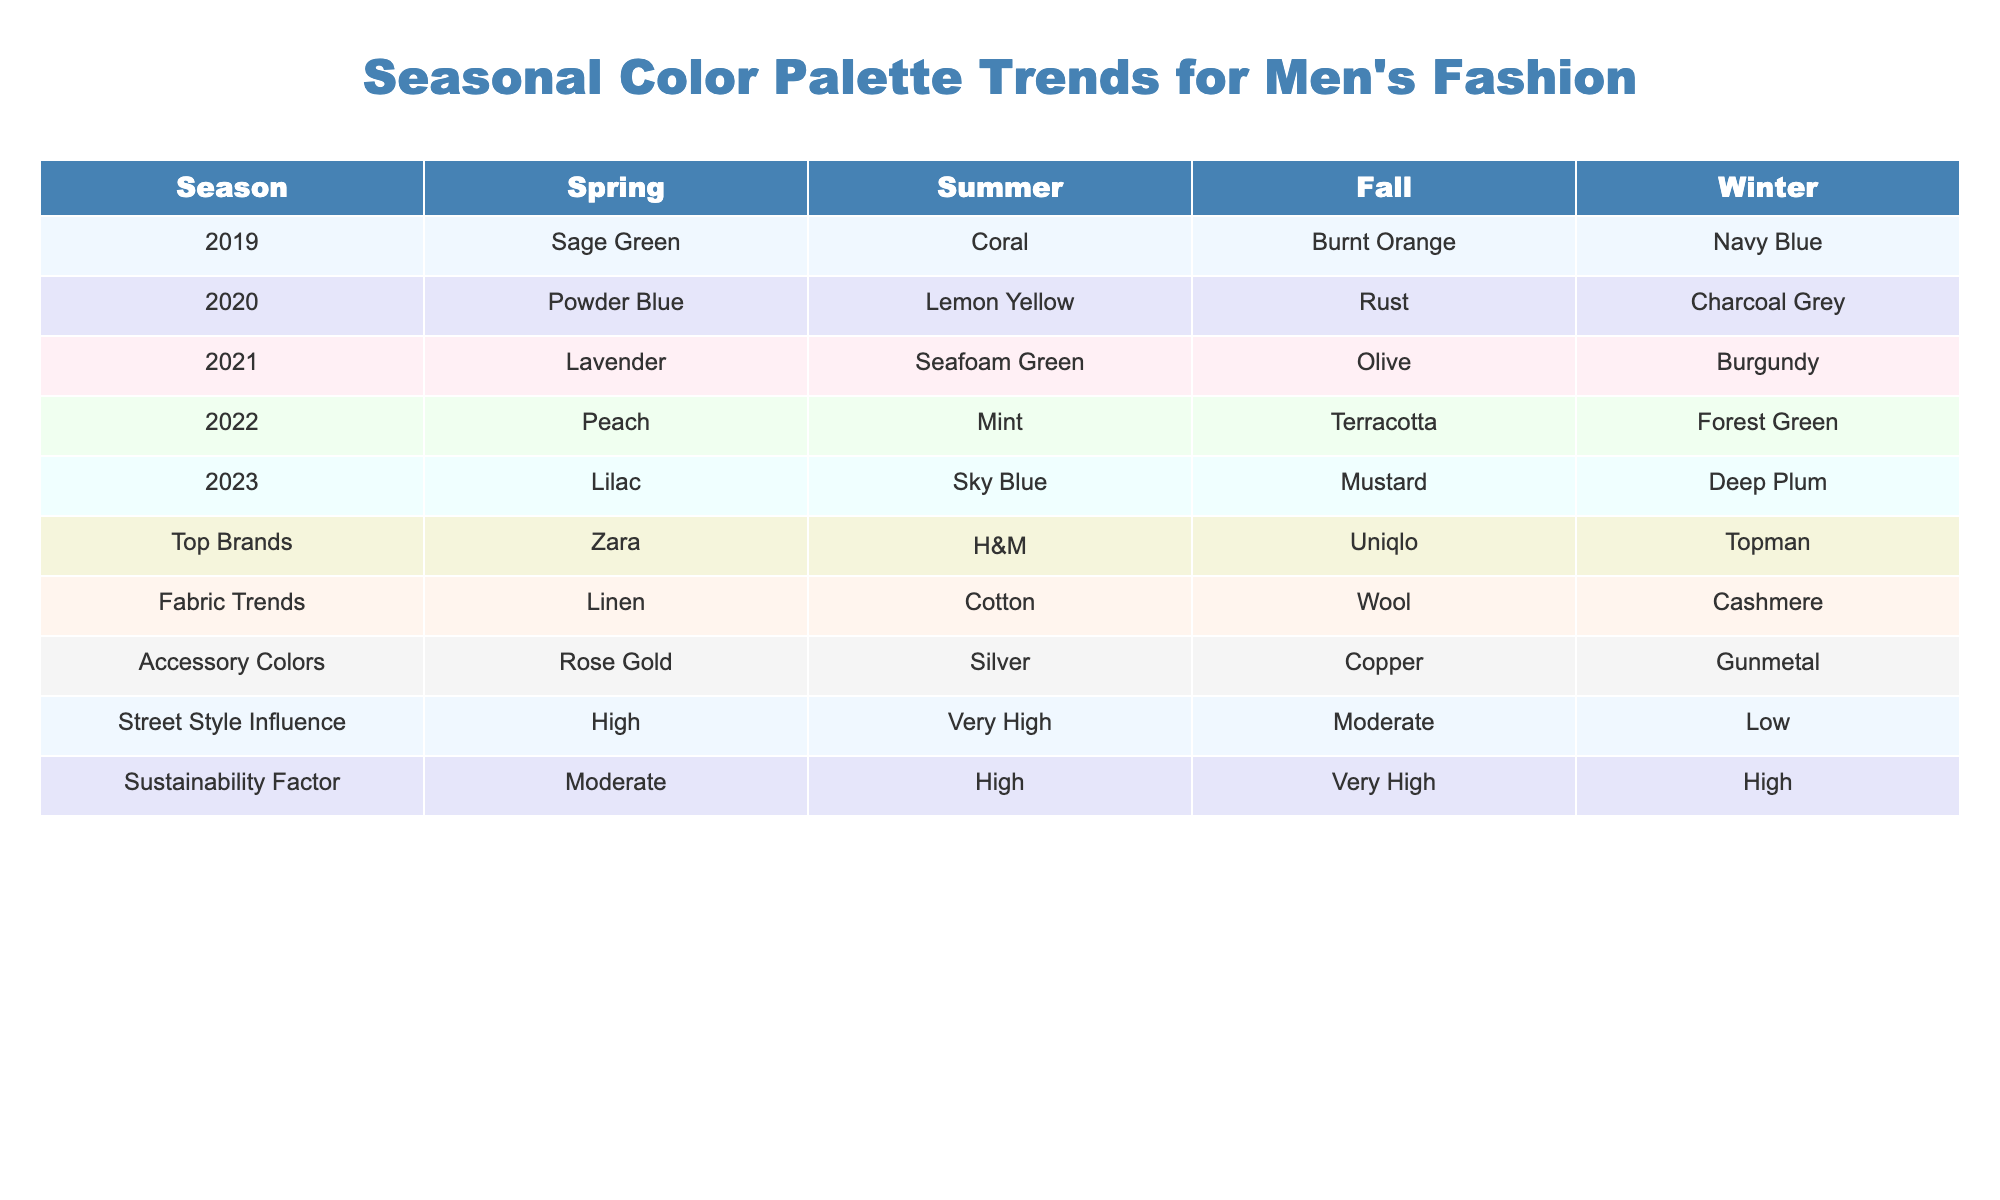What was the color for Spring 2022? The table lists the Spring color for 2022 as Peach.
Answer: Peach Which color was used for Winter in 2020? According to the table, the color for Winter in 2020 was Charcoal Grey.
Answer: Charcoal Grey What is the top brand listed for Fall 2021? The top brand for Fall 2021, as shown in the table, is Uniqlo.
Answer: Uniqlo Is Sage Green present in the Summer palette? The table indicates that Sage Green is only in the Spring palette and not present in any Summer palette, so the answer is no.
Answer: No Which seasonal color palette had a 'High' sustainability factor? By checking the sustainability factors, both Spring 2020 and Summer 2022 have a 'High' sustainability factor.
Answer: Spring 2020 and Summer 2022 What is the difference in accessory colors between Spring and Fall of 2021? The accessory color for Spring 2021 is Rose Gold, while Fall 2021 has Copper. The difference thus is Rose Gold to Copper.
Answer: Rose Gold to Copper In what season was Seafoam Green the color trend? Seafoam Green appears in the Summer season, as per the data.
Answer: Summer What are the colors that trend for Fall from 2019 to 2023 in order? The Fall trend colors from 2019 to 2023 are Burnt Orange, Rust, Olive, Terracotta, and Mustard.
Answer: Burnt Orange, Rust, Olive, Terracotta, Mustard Which year had the lowest street style influence according to the table? Looking at the street style influence, Winter has 'Low' for 2019 which is the lowest compared to others.
Answer: 2019 How would you rank the sustainability factors from Spring to Winter for 2022? The sustainability factors from Spring (Moderate) to Winter (High) in 2022 can be ranked as: 1. Spring (Moderate), 2. Summer (High), 3. Fall (Very High), 4. Winter (High).
Answer: Moderate, High, Very High, High What colors are dominant in the Winter palette over the last five years? The Winter palettes over the years are Navy Blue, Charcoal Grey, Burgundy, Forest Green, and Deep Plum.
Answer: Navy Blue, Charcoal Grey, Burgundy, Forest Green, Deep Plum In which year did the Summer color trend include the highest influence from street style? The highest street style influence is noted as 'Very High' in Summer 2020, making it the most influenced year.
Answer: 2020 